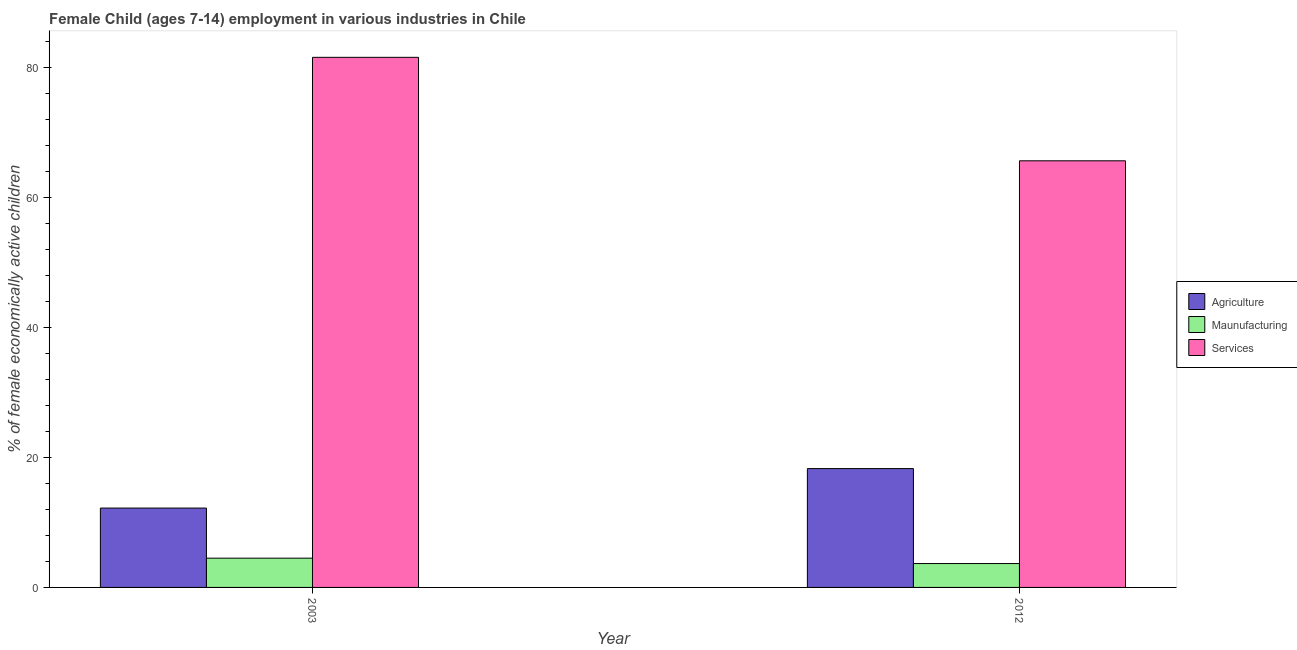Are the number of bars per tick equal to the number of legend labels?
Your answer should be very brief. Yes. How many bars are there on the 1st tick from the left?
Offer a terse response. 3. How many bars are there on the 1st tick from the right?
Your answer should be compact. 3. What is the label of the 1st group of bars from the left?
Your response must be concise. 2003. What is the percentage of economically active children in manufacturing in 2012?
Ensure brevity in your answer.  3.67. Across all years, what is the minimum percentage of economically active children in agriculture?
Your answer should be compact. 12.2. What is the total percentage of economically active children in services in the graph?
Your answer should be compact. 147.09. What is the difference between the percentage of economically active children in manufacturing in 2003 and that in 2012?
Keep it short and to the point. 0.83. What is the difference between the percentage of economically active children in services in 2003 and the percentage of economically active children in manufacturing in 2012?
Your response must be concise. 15.91. What is the average percentage of economically active children in services per year?
Make the answer very short. 73.55. In the year 2012, what is the difference between the percentage of economically active children in agriculture and percentage of economically active children in services?
Your answer should be very brief. 0. What is the ratio of the percentage of economically active children in services in 2003 to that in 2012?
Provide a short and direct response. 1.24. What does the 2nd bar from the left in 2003 represents?
Provide a short and direct response. Maunufacturing. What does the 2nd bar from the right in 2012 represents?
Your answer should be compact. Maunufacturing. Is it the case that in every year, the sum of the percentage of economically active children in agriculture and percentage of economically active children in manufacturing is greater than the percentage of economically active children in services?
Offer a terse response. No. How many years are there in the graph?
Give a very brief answer. 2. Are the values on the major ticks of Y-axis written in scientific E-notation?
Your answer should be compact. No. Does the graph contain grids?
Your response must be concise. No. Where does the legend appear in the graph?
Provide a short and direct response. Center right. What is the title of the graph?
Give a very brief answer. Female Child (ages 7-14) employment in various industries in Chile. What is the label or title of the X-axis?
Keep it short and to the point. Year. What is the label or title of the Y-axis?
Your response must be concise. % of female economically active children. What is the % of female economically active children in Services in 2003?
Give a very brief answer. 81.5. What is the % of female economically active children of Agriculture in 2012?
Provide a succinct answer. 18.27. What is the % of female economically active children in Maunufacturing in 2012?
Your response must be concise. 3.67. What is the % of female economically active children in Services in 2012?
Ensure brevity in your answer.  65.59. Across all years, what is the maximum % of female economically active children in Agriculture?
Provide a succinct answer. 18.27. Across all years, what is the maximum % of female economically active children in Maunufacturing?
Ensure brevity in your answer.  4.5. Across all years, what is the maximum % of female economically active children of Services?
Your answer should be compact. 81.5. Across all years, what is the minimum % of female economically active children in Agriculture?
Offer a terse response. 12.2. Across all years, what is the minimum % of female economically active children in Maunufacturing?
Your answer should be compact. 3.67. Across all years, what is the minimum % of female economically active children in Services?
Make the answer very short. 65.59. What is the total % of female economically active children in Agriculture in the graph?
Ensure brevity in your answer.  30.47. What is the total % of female economically active children in Maunufacturing in the graph?
Provide a succinct answer. 8.17. What is the total % of female economically active children in Services in the graph?
Provide a succinct answer. 147.09. What is the difference between the % of female economically active children of Agriculture in 2003 and that in 2012?
Ensure brevity in your answer.  -6.07. What is the difference between the % of female economically active children in Maunufacturing in 2003 and that in 2012?
Your answer should be compact. 0.83. What is the difference between the % of female economically active children in Services in 2003 and that in 2012?
Give a very brief answer. 15.91. What is the difference between the % of female economically active children of Agriculture in 2003 and the % of female economically active children of Maunufacturing in 2012?
Your response must be concise. 8.53. What is the difference between the % of female economically active children in Agriculture in 2003 and the % of female economically active children in Services in 2012?
Ensure brevity in your answer.  -53.39. What is the difference between the % of female economically active children of Maunufacturing in 2003 and the % of female economically active children of Services in 2012?
Your answer should be very brief. -61.09. What is the average % of female economically active children of Agriculture per year?
Your answer should be compact. 15.23. What is the average % of female economically active children in Maunufacturing per year?
Your answer should be very brief. 4.08. What is the average % of female economically active children in Services per year?
Your response must be concise. 73.55. In the year 2003, what is the difference between the % of female economically active children of Agriculture and % of female economically active children of Maunufacturing?
Offer a terse response. 7.7. In the year 2003, what is the difference between the % of female economically active children in Agriculture and % of female economically active children in Services?
Your answer should be compact. -69.3. In the year 2003, what is the difference between the % of female economically active children of Maunufacturing and % of female economically active children of Services?
Offer a terse response. -77. In the year 2012, what is the difference between the % of female economically active children in Agriculture and % of female economically active children in Services?
Provide a succinct answer. -47.32. In the year 2012, what is the difference between the % of female economically active children of Maunufacturing and % of female economically active children of Services?
Your answer should be compact. -61.92. What is the ratio of the % of female economically active children of Agriculture in 2003 to that in 2012?
Your answer should be very brief. 0.67. What is the ratio of the % of female economically active children in Maunufacturing in 2003 to that in 2012?
Give a very brief answer. 1.23. What is the ratio of the % of female economically active children in Services in 2003 to that in 2012?
Provide a short and direct response. 1.24. What is the difference between the highest and the second highest % of female economically active children in Agriculture?
Keep it short and to the point. 6.07. What is the difference between the highest and the second highest % of female economically active children of Maunufacturing?
Provide a succinct answer. 0.83. What is the difference between the highest and the second highest % of female economically active children of Services?
Provide a succinct answer. 15.91. What is the difference between the highest and the lowest % of female economically active children in Agriculture?
Your answer should be very brief. 6.07. What is the difference between the highest and the lowest % of female economically active children of Maunufacturing?
Your answer should be compact. 0.83. What is the difference between the highest and the lowest % of female economically active children in Services?
Offer a terse response. 15.91. 